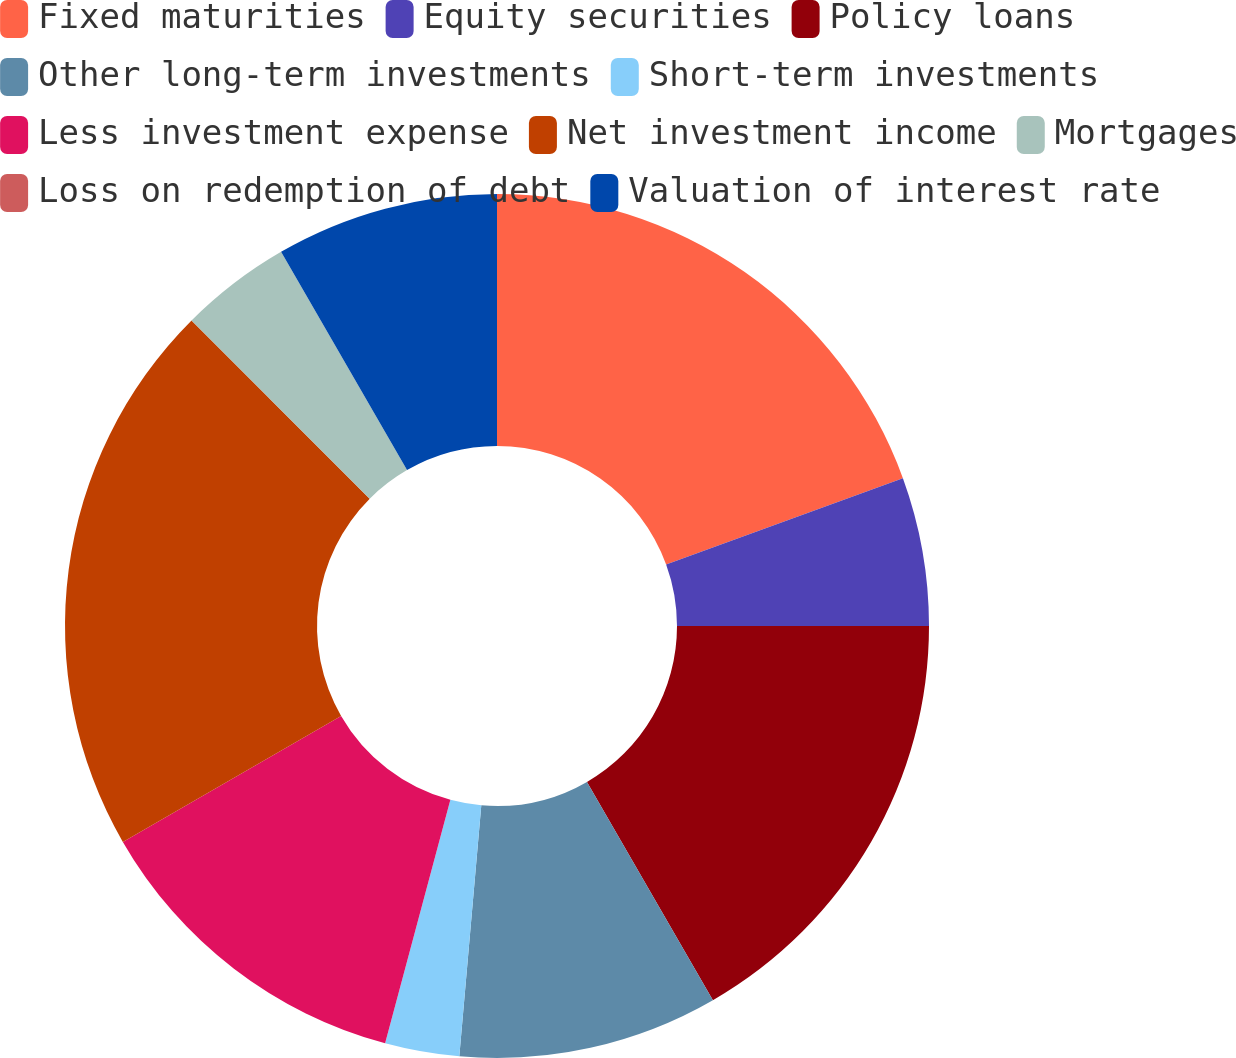Convert chart. <chart><loc_0><loc_0><loc_500><loc_500><pie_chart><fcel>Fixed maturities<fcel>Equity securities<fcel>Policy loans<fcel>Other long-term investments<fcel>Short-term investments<fcel>Less investment expense<fcel>Net investment income<fcel>Mortgages<fcel>Loss on redemption of debt<fcel>Valuation of interest rate<nl><fcel>19.44%<fcel>5.56%<fcel>16.67%<fcel>9.72%<fcel>2.78%<fcel>12.5%<fcel>20.83%<fcel>4.17%<fcel>0.0%<fcel>8.33%<nl></chart> 